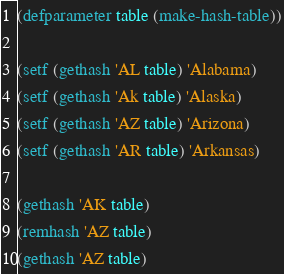Convert code to text. <code><loc_0><loc_0><loc_500><loc_500><_Lisp_>(defparameter table (make-hash-table))

(setf (gethash 'AL table) 'Alabama)
(setf (gethash 'Ak table) 'Alaska)
(setf (gethash 'AZ table) 'Arizona)
(setf (gethash 'AR table) 'Arkansas)

(gethash 'AK table)
(remhash 'AZ table)
(gethash 'AZ table)</code> 